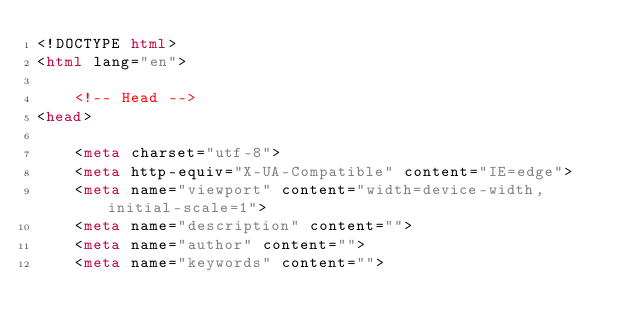<code> <loc_0><loc_0><loc_500><loc_500><_HTML_><!DOCTYPE html>
<html lang="en">

    <!-- Head -->
<head>
    
    <meta charset="utf-8">
    <meta http-equiv="X-UA-Compatible" content="IE=edge">
    <meta name="viewport" content="width=device-width, initial-scale=1">
    <meta name="description" content="">
    <meta name="author" content="">
    <meta name="keywords" content=""></code> 